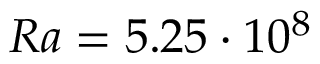Convert formula to latex. <formula><loc_0><loc_0><loc_500><loc_500>R a = 5 . 2 5 \cdot 1 0 ^ { 8 }</formula> 